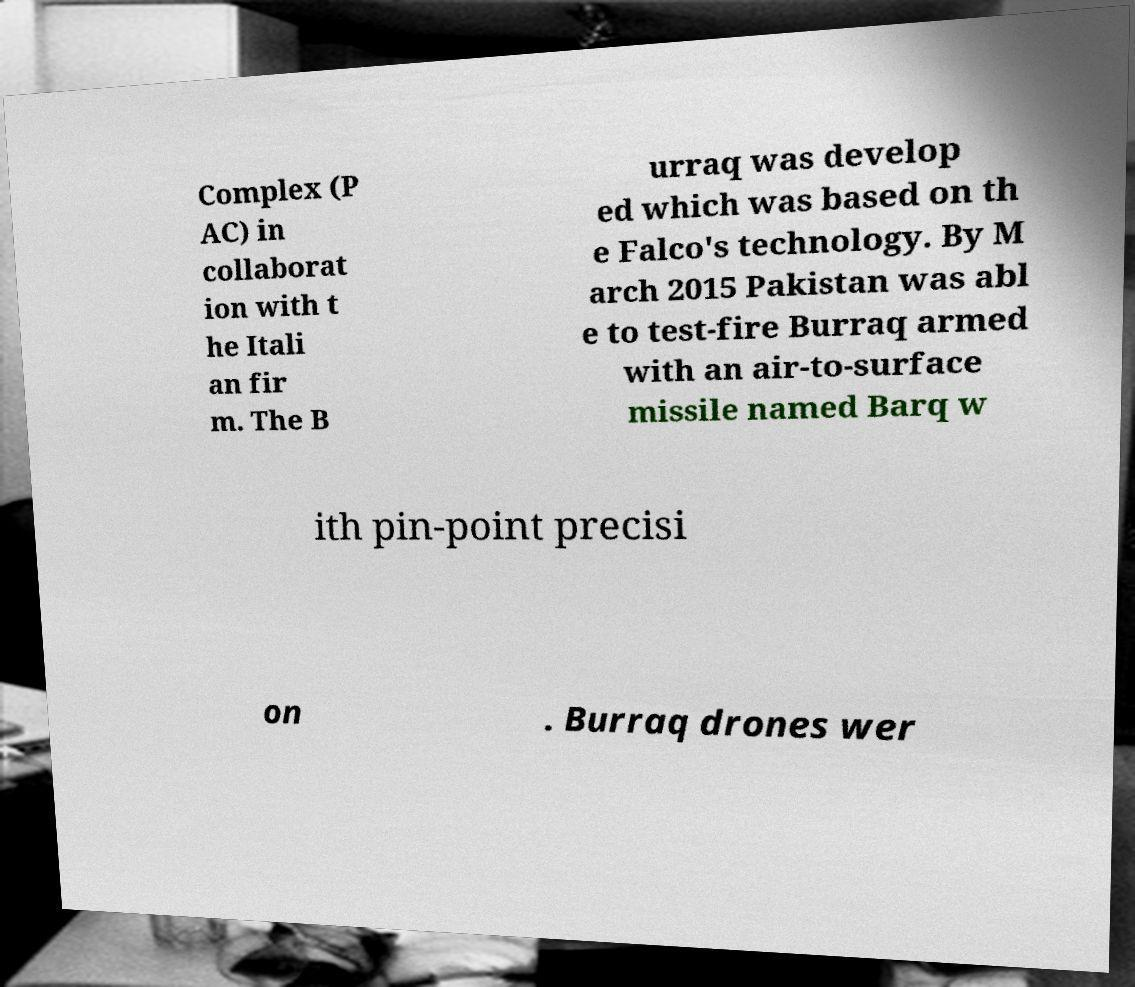Could you extract and type out the text from this image? Complex (P AC) in collaborat ion with t he Itali an fir m. The B urraq was develop ed which was based on th e Falco's technology. By M arch 2015 Pakistan was abl e to test-fire Burraq armed with an air-to-surface missile named Barq w ith pin-point precisi on . Burraq drones wer 